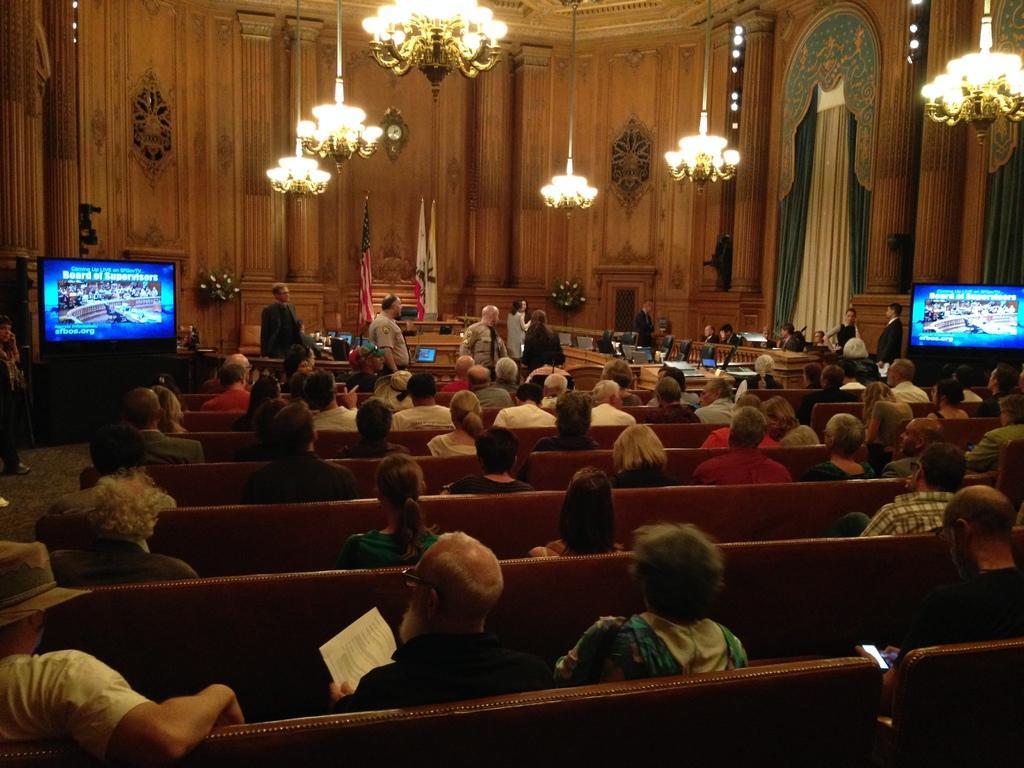Could you give a brief overview of what you see in this image? In this picture I can see a number of people sitting on the chair. I can see tables. I can see the flags. I can see televisions on the left and right side. I can see a number of chandeliers. 